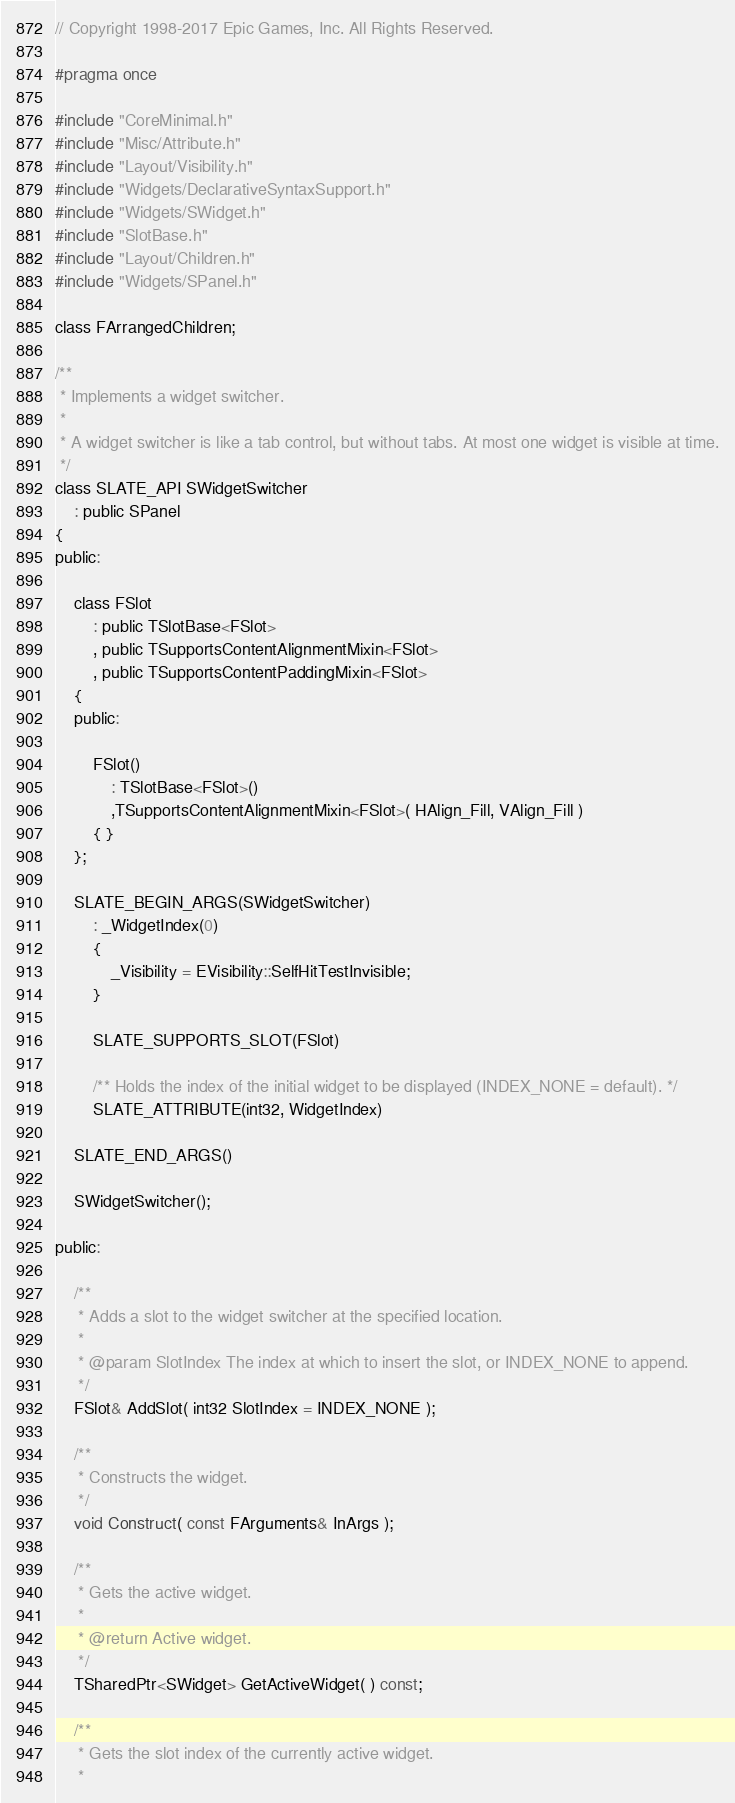Convert code to text. <code><loc_0><loc_0><loc_500><loc_500><_C_>// Copyright 1998-2017 Epic Games, Inc. All Rights Reserved.

#pragma once

#include "CoreMinimal.h"
#include "Misc/Attribute.h"
#include "Layout/Visibility.h"
#include "Widgets/DeclarativeSyntaxSupport.h"
#include "Widgets/SWidget.h"
#include "SlotBase.h"
#include "Layout/Children.h"
#include "Widgets/SPanel.h"

class FArrangedChildren;

/**
 * Implements a widget switcher.
 *
 * A widget switcher is like a tab control, but without tabs. At most one widget is visible at time.
 */
class SLATE_API SWidgetSwitcher
	: public SPanel
{
public:

	class FSlot
		: public TSlotBase<FSlot>
		, public TSupportsContentAlignmentMixin<FSlot>
		, public TSupportsContentPaddingMixin<FSlot>
	{
	public:

		FSlot()
			: TSlotBase<FSlot>()
			,TSupportsContentAlignmentMixin<FSlot>( HAlign_Fill, VAlign_Fill )
		{ }
	};

	SLATE_BEGIN_ARGS(SWidgetSwitcher)
		: _WidgetIndex(0)
		{
			_Visibility = EVisibility::SelfHitTestInvisible;
		}

		SLATE_SUPPORTS_SLOT(FSlot)

		/** Holds the index of the initial widget to be displayed (INDEX_NONE = default). */
		SLATE_ATTRIBUTE(int32, WidgetIndex)

	SLATE_END_ARGS()

	SWidgetSwitcher();

public:

	/**
	 * Adds a slot to the widget switcher at the specified location.
	 *
	 * @param SlotIndex The index at which to insert the slot, or INDEX_NONE to append.
	 */
	FSlot& AddSlot( int32 SlotIndex = INDEX_NONE );

	/**
	 * Constructs the widget.
	 */
	void Construct( const FArguments& InArgs );

	/**
	 * Gets the active widget.
	 *
	 * @return Active widget.
	 */
	TSharedPtr<SWidget> GetActiveWidget( ) const;

	/**
	 * Gets the slot index of the currently active widget.
	 *</code> 